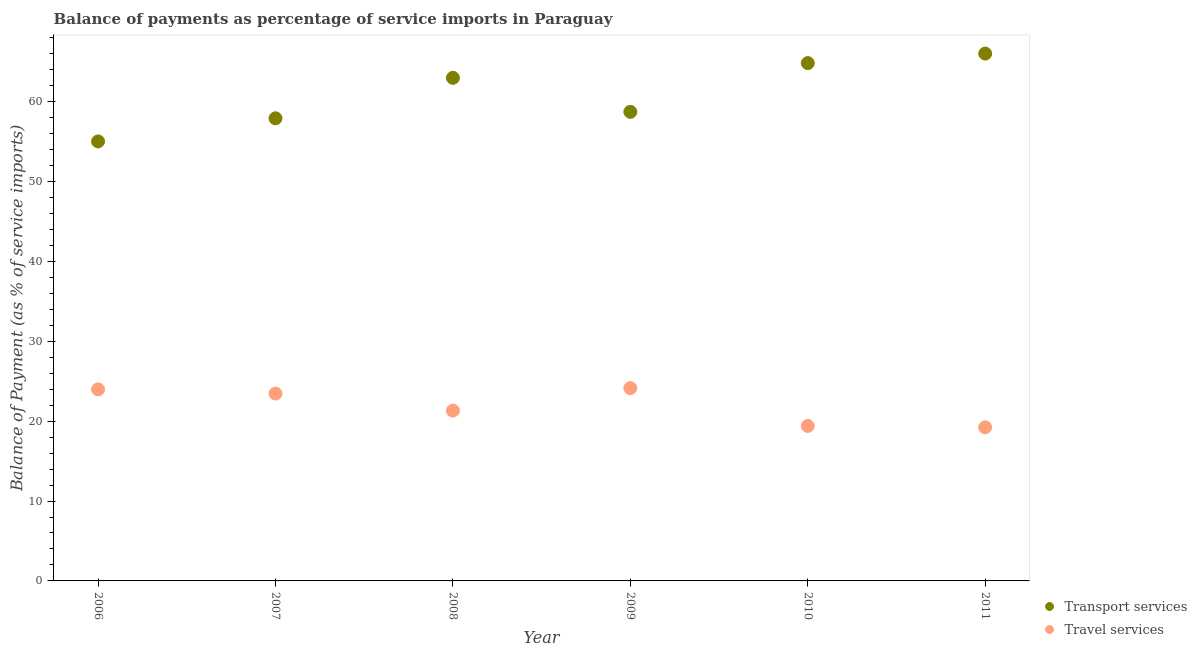What is the balance of payments of transport services in 2006?
Ensure brevity in your answer.  55.01. Across all years, what is the maximum balance of payments of transport services?
Ensure brevity in your answer.  66. Across all years, what is the minimum balance of payments of transport services?
Your answer should be compact. 55.01. In which year was the balance of payments of travel services maximum?
Your answer should be compact. 2009. In which year was the balance of payments of transport services minimum?
Keep it short and to the point. 2006. What is the total balance of payments of transport services in the graph?
Your answer should be very brief. 365.4. What is the difference between the balance of payments of transport services in 2009 and that in 2010?
Your answer should be very brief. -6.1. What is the difference between the balance of payments of transport services in 2006 and the balance of payments of travel services in 2008?
Ensure brevity in your answer.  33.69. What is the average balance of payments of transport services per year?
Keep it short and to the point. 60.9. In the year 2008, what is the difference between the balance of payments of transport services and balance of payments of travel services?
Offer a very short reply. 41.65. What is the ratio of the balance of payments of travel services in 2008 to that in 2011?
Offer a terse response. 1.11. What is the difference between the highest and the second highest balance of payments of travel services?
Offer a terse response. 0.15. What is the difference between the highest and the lowest balance of payments of transport services?
Ensure brevity in your answer.  10.99. In how many years, is the balance of payments of travel services greater than the average balance of payments of travel services taken over all years?
Your response must be concise. 3. Does the balance of payments of transport services monotonically increase over the years?
Make the answer very short. No. How many years are there in the graph?
Your answer should be very brief. 6. Does the graph contain any zero values?
Make the answer very short. No. Does the graph contain grids?
Your answer should be very brief. No. Where does the legend appear in the graph?
Your answer should be very brief. Bottom right. How many legend labels are there?
Provide a short and direct response. 2. What is the title of the graph?
Make the answer very short. Balance of payments as percentage of service imports in Paraguay. Does "Fertility rate" appear as one of the legend labels in the graph?
Offer a very short reply. No. What is the label or title of the Y-axis?
Offer a very short reply. Balance of Payment (as % of service imports). What is the Balance of Payment (as % of service imports) in Transport services in 2006?
Your response must be concise. 55.01. What is the Balance of Payment (as % of service imports) in Travel services in 2006?
Provide a short and direct response. 23.98. What is the Balance of Payment (as % of service imports) in Transport services in 2007?
Ensure brevity in your answer.  57.9. What is the Balance of Payment (as % of service imports) of Travel services in 2007?
Your answer should be very brief. 23.45. What is the Balance of Payment (as % of service imports) of Transport services in 2008?
Make the answer very short. 62.97. What is the Balance of Payment (as % of service imports) of Travel services in 2008?
Offer a very short reply. 21.32. What is the Balance of Payment (as % of service imports) in Transport services in 2009?
Make the answer very short. 58.71. What is the Balance of Payment (as % of service imports) of Travel services in 2009?
Your answer should be compact. 24.13. What is the Balance of Payment (as % of service imports) of Transport services in 2010?
Ensure brevity in your answer.  64.81. What is the Balance of Payment (as % of service imports) of Travel services in 2010?
Offer a very short reply. 19.4. What is the Balance of Payment (as % of service imports) of Transport services in 2011?
Provide a succinct answer. 66. What is the Balance of Payment (as % of service imports) in Travel services in 2011?
Your answer should be compact. 19.22. Across all years, what is the maximum Balance of Payment (as % of service imports) of Transport services?
Provide a succinct answer. 66. Across all years, what is the maximum Balance of Payment (as % of service imports) in Travel services?
Offer a very short reply. 24.13. Across all years, what is the minimum Balance of Payment (as % of service imports) of Transport services?
Make the answer very short. 55.01. Across all years, what is the minimum Balance of Payment (as % of service imports) in Travel services?
Keep it short and to the point. 19.22. What is the total Balance of Payment (as % of service imports) in Transport services in the graph?
Your answer should be very brief. 365.4. What is the total Balance of Payment (as % of service imports) of Travel services in the graph?
Provide a succinct answer. 131.49. What is the difference between the Balance of Payment (as % of service imports) in Transport services in 2006 and that in 2007?
Provide a short and direct response. -2.89. What is the difference between the Balance of Payment (as % of service imports) of Travel services in 2006 and that in 2007?
Keep it short and to the point. 0.53. What is the difference between the Balance of Payment (as % of service imports) of Transport services in 2006 and that in 2008?
Your answer should be very brief. -7.96. What is the difference between the Balance of Payment (as % of service imports) in Travel services in 2006 and that in 2008?
Provide a succinct answer. 2.66. What is the difference between the Balance of Payment (as % of service imports) of Transport services in 2006 and that in 2009?
Offer a very short reply. -3.7. What is the difference between the Balance of Payment (as % of service imports) in Travel services in 2006 and that in 2009?
Keep it short and to the point. -0.15. What is the difference between the Balance of Payment (as % of service imports) of Transport services in 2006 and that in 2010?
Your answer should be very brief. -9.8. What is the difference between the Balance of Payment (as % of service imports) of Travel services in 2006 and that in 2010?
Provide a succinct answer. 4.58. What is the difference between the Balance of Payment (as % of service imports) in Transport services in 2006 and that in 2011?
Offer a very short reply. -10.99. What is the difference between the Balance of Payment (as % of service imports) in Travel services in 2006 and that in 2011?
Provide a succinct answer. 4.75. What is the difference between the Balance of Payment (as % of service imports) of Transport services in 2007 and that in 2008?
Your response must be concise. -5.06. What is the difference between the Balance of Payment (as % of service imports) of Travel services in 2007 and that in 2008?
Offer a very short reply. 2.13. What is the difference between the Balance of Payment (as % of service imports) in Transport services in 2007 and that in 2009?
Provide a succinct answer. -0.81. What is the difference between the Balance of Payment (as % of service imports) of Travel services in 2007 and that in 2009?
Offer a very short reply. -0.68. What is the difference between the Balance of Payment (as % of service imports) in Transport services in 2007 and that in 2010?
Your answer should be very brief. -6.91. What is the difference between the Balance of Payment (as % of service imports) in Travel services in 2007 and that in 2010?
Provide a succinct answer. 4.05. What is the difference between the Balance of Payment (as % of service imports) in Transport services in 2007 and that in 2011?
Your answer should be very brief. -8.1. What is the difference between the Balance of Payment (as % of service imports) in Travel services in 2007 and that in 2011?
Your response must be concise. 4.23. What is the difference between the Balance of Payment (as % of service imports) in Transport services in 2008 and that in 2009?
Provide a succinct answer. 4.26. What is the difference between the Balance of Payment (as % of service imports) of Travel services in 2008 and that in 2009?
Provide a succinct answer. -2.81. What is the difference between the Balance of Payment (as % of service imports) of Transport services in 2008 and that in 2010?
Offer a very short reply. -1.85. What is the difference between the Balance of Payment (as % of service imports) of Travel services in 2008 and that in 2010?
Your answer should be very brief. 1.92. What is the difference between the Balance of Payment (as % of service imports) of Transport services in 2008 and that in 2011?
Keep it short and to the point. -3.04. What is the difference between the Balance of Payment (as % of service imports) of Travel services in 2008 and that in 2011?
Your response must be concise. 2.1. What is the difference between the Balance of Payment (as % of service imports) of Transport services in 2009 and that in 2010?
Provide a succinct answer. -6.1. What is the difference between the Balance of Payment (as % of service imports) of Travel services in 2009 and that in 2010?
Your response must be concise. 4.73. What is the difference between the Balance of Payment (as % of service imports) of Transport services in 2009 and that in 2011?
Make the answer very short. -7.29. What is the difference between the Balance of Payment (as % of service imports) of Travel services in 2009 and that in 2011?
Your answer should be compact. 4.91. What is the difference between the Balance of Payment (as % of service imports) of Transport services in 2010 and that in 2011?
Your answer should be compact. -1.19. What is the difference between the Balance of Payment (as % of service imports) of Travel services in 2010 and that in 2011?
Offer a very short reply. 0.18. What is the difference between the Balance of Payment (as % of service imports) in Transport services in 2006 and the Balance of Payment (as % of service imports) in Travel services in 2007?
Ensure brevity in your answer.  31.56. What is the difference between the Balance of Payment (as % of service imports) in Transport services in 2006 and the Balance of Payment (as % of service imports) in Travel services in 2008?
Offer a very short reply. 33.69. What is the difference between the Balance of Payment (as % of service imports) in Transport services in 2006 and the Balance of Payment (as % of service imports) in Travel services in 2009?
Offer a terse response. 30.88. What is the difference between the Balance of Payment (as % of service imports) in Transport services in 2006 and the Balance of Payment (as % of service imports) in Travel services in 2010?
Give a very brief answer. 35.61. What is the difference between the Balance of Payment (as % of service imports) in Transport services in 2006 and the Balance of Payment (as % of service imports) in Travel services in 2011?
Give a very brief answer. 35.79. What is the difference between the Balance of Payment (as % of service imports) of Transport services in 2007 and the Balance of Payment (as % of service imports) of Travel services in 2008?
Your response must be concise. 36.58. What is the difference between the Balance of Payment (as % of service imports) in Transport services in 2007 and the Balance of Payment (as % of service imports) in Travel services in 2009?
Provide a succinct answer. 33.77. What is the difference between the Balance of Payment (as % of service imports) of Transport services in 2007 and the Balance of Payment (as % of service imports) of Travel services in 2010?
Provide a succinct answer. 38.5. What is the difference between the Balance of Payment (as % of service imports) in Transport services in 2007 and the Balance of Payment (as % of service imports) in Travel services in 2011?
Your answer should be very brief. 38.68. What is the difference between the Balance of Payment (as % of service imports) in Transport services in 2008 and the Balance of Payment (as % of service imports) in Travel services in 2009?
Your response must be concise. 38.83. What is the difference between the Balance of Payment (as % of service imports) of Transport services in 2008 and the Balance of Payment (as % of service imports) of Travel services in 2010?
Offer a terse response. 43.57. What is the difference between the Balance of Payment (as % of service imports) in Transport services in 2008 and the Balance of Payment (as % of service imports) in Travel services in 2011?
Provide a short and direct response. 43.74. What is the difference between the Balance of Payment (as % of service imports) in Transport services in 2009 and the Balance of Payment (as % of service imports) in Travel services in 2010?
Provide a short and direct response. 39.31. What is the difference between the Balance of Payment (as % of service imports) in Transport services in 2009 and the Balance of Payment (as % of service imports) in Travel services in 2011?
Ensure brevity in your answer.  39.49. What is the difference between the Balance of Payment (as % of service imports) in Transport services in 2010 and the Balance of Payment (as % of service imports) in Travel services in 2011?
Your answer should be compact. 45.59. What is the average Balance of Payment (as % of service imports) in Transport services per year?
Offer a terse response. 60.9. What is the average Balance of Payment (as % of service imports) in Travel services per year?
Your response must be concise. 21.92. In the year 2006, what is the difference between the Balance of Payment (as % of service imports) in Transport services and Balance of Payment (as % of service imports) in Travel services?
Your response must be concise. 31.03. In the year 2007, what is the difference between the Balance of Payment (as % of service imports) in Transport services and Balance of Payment (as % of service imports) in Travel services?
Make the answer very short. 34.46. In the year 2008, what is the difference between the Balance of Payment (as % of service imports) of Transport services and Balance of Payment (as % of service imports) of Travel services?
Your answer should be compact. 41.65. In the year 2009, what is the difference between the Balance of Payment (as % of service imports) in Transport services and Balance of Payment (as % of service imports) in Travel services?
Your response must be concise. 34.58. In the year 2010, what is the difference between the Balance of Payment (as % of service imports) of Transport services and Balance of Payment (as % of service imports) of Travel services?
Your response must be concise. 45.41. In the year 2011, what is the difference between the Balance of Payment (as % of service imports) in Transport services and Balance of Payment (as % of service imports) in Travel services?
Give a very brief answer. 46.78. What is the ratio of the Balance of Payment (as % of service imports) in Transport services in 2006 to that in 2007?
Ensure brevity in your answer.  0.95. What is the ratio of the Balance of Payment (as % of service imports) of Travel services in 2006 to that in 2007?
Provide a short and direct response. 1.02. What is the ratio of the Balance of Payment (as % of service imports) in Transport services in 2006 to that in 2008?
Your answer should be compact. 0.87. What is the ratio of the Balance of Payment (as % of service imports) in Travel services in 2006 to that in 2008?
Your response must be concise. 1.12. What is the ratio of the Balance of Payment (as % of service imports) of Transport services in 2006 to that in 2009?
Ensure brevity in your answer.  0.94. What is the ratio of the Balance of Payment (as % of service imports) of Travel services in 2006 to that in 2009?
Give a very brief answer. 0.99. What is the ratio of the Balance of Payment (as % of service imports) of Transport services in 2006 to that in 2010?
Provide a short and direct response. 0.85. What is the ratio of the Balance of Payment (as % of service imports) in Travel services in 2006 to that in 2010?
Make the answer very short. 1.24. What is the ratio of the Balance of Payment (as % of service imports) of Transport services in 2006 to that in 2011?
Ensure brevity in your answer.  0.83. What is the ratio of the Balance of Payment (as % of service imports) of Travel services in 2006 to that in 2011?
Offer a very short reply. 1.25. What is the ratio of the Balance of Payment (as % of service imports) in Transport services in 2007 to that in 2008?
Provide a short and direct response. 0.92. What is the ratio of the Balance of Payment (as % of service imports) of Travel services in 2007 to that in 2008?
Offer a terse response. 1.1. What is the ratio of the Balance of Payment (as % of service imports) in Transport services in 2007 to that in 2009?
Offer a very short reply. 0.99. What is the ratio of the Balance of Payment (as % of service imports) in Travel services in 2007 to that in 2009?
Keep it short and to the point. 0.97. What is the ratio of the Balance of Payment (as % of service imports) in Transport services in 2007 to that in 2010?
Your answer should be very brief. 0.89. What is the ratio of the Balance of Payment (as % of service imports) of Travel services in 2007 to that in 2010?
Make the answer very short. 1.21. What is the ratio of the Balance of Payment (as % of service imports) of Transport services in 2007 to that in 2011?
Offer a very short reply. 0.88. What is the ratio of the Balance of Payment (as % of service imports) of Travel services in 2007 to that in 2011?
Keep it short and to the point. 1.22. What is the ratio of the Balance of Payment (as % of service imports) in Transport services in 2008 to that in 2009?
Make the answer very short. 1.07. What is the ratio of the Balance of Payment (as % of service imports) of Travel services in 2008 to that in 2009?
Provide a succinct answer. 0.88. What is the ratio of the Balance of Payment (as % of service imports) of Transport services in 2008 to that in 2010?
Your answer should be compact. 0.97. What is the ratio of the Balance of Payment (as % of service imports) of Travel services in 2008 to that in 2010?
Make the answer very short. 1.1. What is the ratio of the Balance of Payment (as % of service imports) in Transport services in 2008 to that in 2011?
Your answer should be very brief. 0.95. What is the ratio of the Balance of Payment (as % of service imports) of Travel services in 2008 to that in 2011?
Offer a terse response. 1.11. What is the ratio of the Balance of Payment (as % of service imports) of Transport services in 2009 to that in 2010?
Ensure brevity in your answer.  0.91. What is the ratio of the Balance of Payment (as % of service imports) of Travel services in 2009 to that in 2010?
Your answer should be compact. 1.24. What is the ratio of the Balance of Payment (as % of service imports) of Transport services in 2009 to that in 2011?
Provide a short and direct response. 0.89. What is the ratio of the Balance of Payment (as % of service imports) in Travel services in 2009 to that in 2011?
Provide a short and direct response. 1.26. What is the ratio of the Balance of Payment (as % of service imports) in Transport services in 2010 to that in 2011?
Your response must be concise. 0.98. What is the ratio of the Balance of Payment (as % of service imports) in Travel services in 2010 to that in 2011?
Provide a short and direct response. 1.01. What is the difference between the highest and the second highest Balance of Payment (as % of service imports) of Transport services?
Your response must be concise. 1.19. What is the difference between the highest and the second highest Balance of Payment (as % of service imports) of Travel services?
Ensure brevity in your answer.  0.15. What is the difference between the highest and the lowest Balance of Payment (as % of service imports) of Transport services?
Your answer should be compact. 10.99. What is the difference between the highest and the lowest Balance of Payment (as % of service imports) of Travel services?
Offer a terse response. 4.91. 